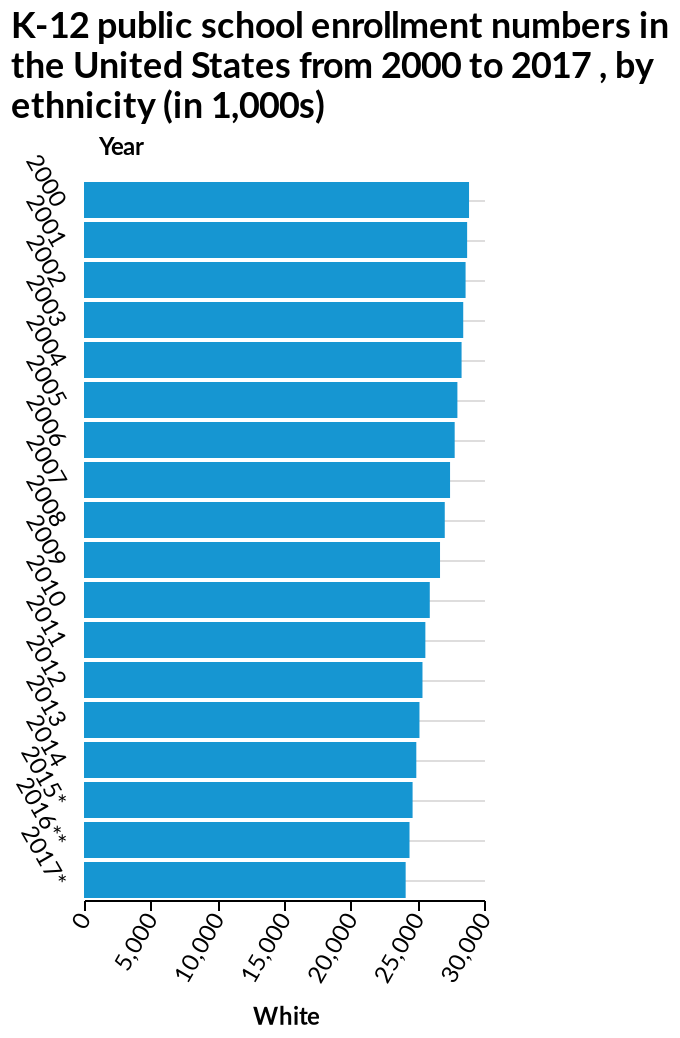<image>
please enumerates aspects of the construction of the chart This bar graph is named K-12 public school enrollment numbers in the United States from 2000 to 2017 , by ethnicity (in 1,000s). Along the x-axis, White is defined. Year is plotted as a categorical scale with 2000 on one end and 2017* at the other along the y-axis. Offer a thorough analysis of the image. The number of white students that enrolled in K-12 public schools from 2000-2017 has steadily declined. please summary the statistics and relations of the chart K12 school enrollment gradually declined by about 5000. What is the name of the bar graph and what does it represent? The bar graph is named "K-12 public school enrollment numbers in the United States from 2000 to 2017, by ethnicity (in 1,000s)". It represents the enrollment numbers of different ethnicities in K-12 public schools in the United States from 2000 to 2017. 